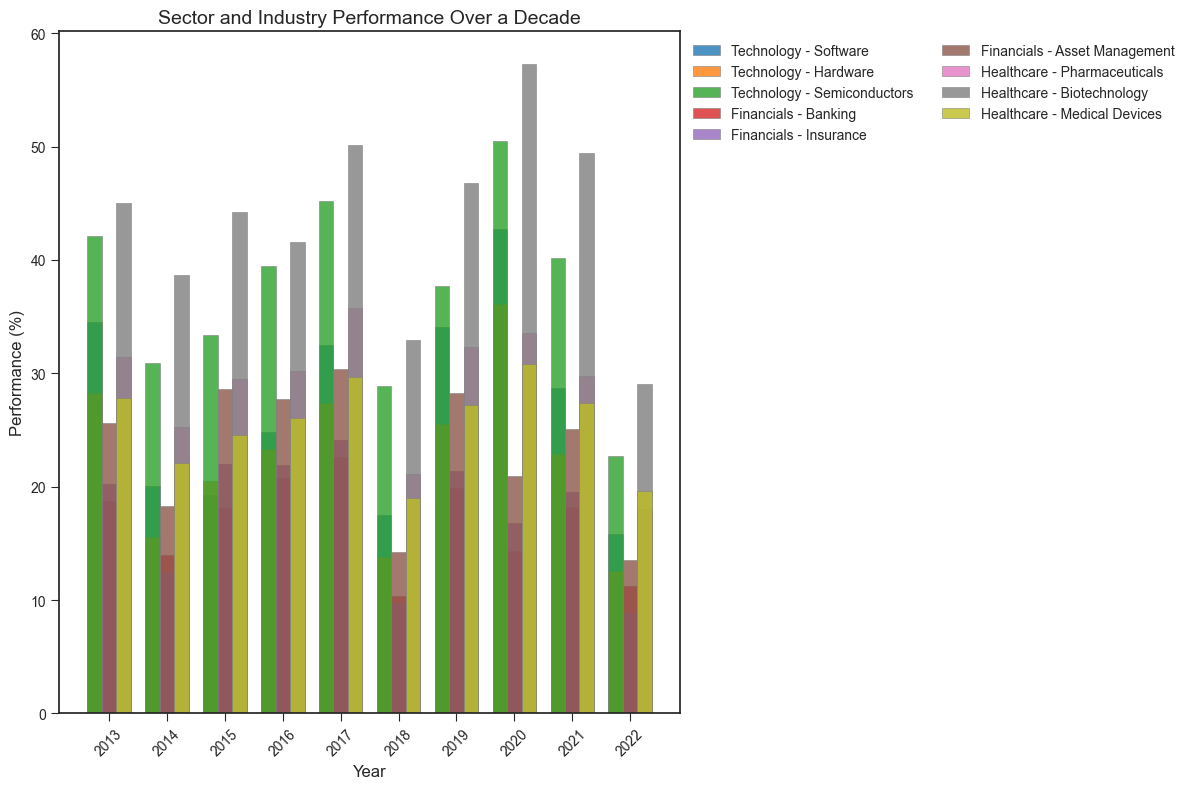Which year had the highest overall performance for the Technology sector? To find the highest overall performance for the Technology sector, identify the highest bar in the bars labeled "Technology". In 2020, the performance values for Software, Hardware, and Semiconductors are 42.7%, 36.1%, and 50.5% respectively, which sum to 129.3%. No other year exceeds this total for Technology.
Answer: 2020 Between Software and Biotechnology industries, which one showed a higher average performance over the decade? To determine this, calculate the average performance for both industries over the years. For Software: (34.5 + 20.1 + 19.3 + 24.8 + 32.5 + 17.5 + 34.1 + 42.7 + 28.7 + 15.8) / 10 = 26.0%. For Biotechnology: (45.0 + 38.7 + 44.2 + 41.6 + 50.1 + 32.9 + 46.8 + 57.3 + 49.4 + 29.1) / 10 = 43.51%. Compare these average values.
Answer: Biotechnology Which industry in the Financials sector experienced the lowest performance in 2018? For 2018, locate the bars labeled "Financials", and look for the shortest bar among Banking, Insurance, and Asset Management. The performance values are Banking (10.4%), Insurance (9.7%), and Asset Management (14.2%). The lowest is Insurance.
Answer: Insurance In which year did the Pharmaceuticals industry within the Healthcare sector have the highest performance? Identify the year where the bar labeled "Pharmaceuticals" under "Healthcare" is the tallest. The performance values for Pharmaceuticals over the years are: 31.4%, 25.3%, 29.5%, 30.2%, 35.8%, 21.1%, 32.3%, 33.6%, 29.8%, 18.0%. The highest value is in 2017 with 35.8%.
Answer: 2017 By how much did the Semiconductors industry outperform the Asset Management industry in 2020? Locate the bars for Semiconductors (Technology) and Asset Management (Financials) for the year 2020. The performance values are 50.5% for Semiconductors and 20.9% for Asset Management. Calculate the difference: 50.5% - 20.9% = 29.6%.
Answer: 29.6% Which industry in the Healthcare sector consistently showed over 25% performance every year? Scan each year's Healthcare performance bars, and identify the bars that are always above the 25% mark. Medical Devices (27.8%, 22.1%, 24.6%, 26.1%, 29.7%, 19.0%, 27.2%, 30.8%, 27.4%, 19.6%) occasionally dips below 25%. Pharmaceuticals (31.4%, 25.3%, 29.5%, 30.2%, 35.8%, 21.1%, 32.3%, 33.6%, 29.8%, 18.0%) also dips below. Biotechnology (45.0%, 38.7%, 44.2%, 41.6%, 50.1%, 32.9%, 46.8%, 57.3%, 49.4%, 29.1%) is consistently above 25%.
Answer: Biotechnology 